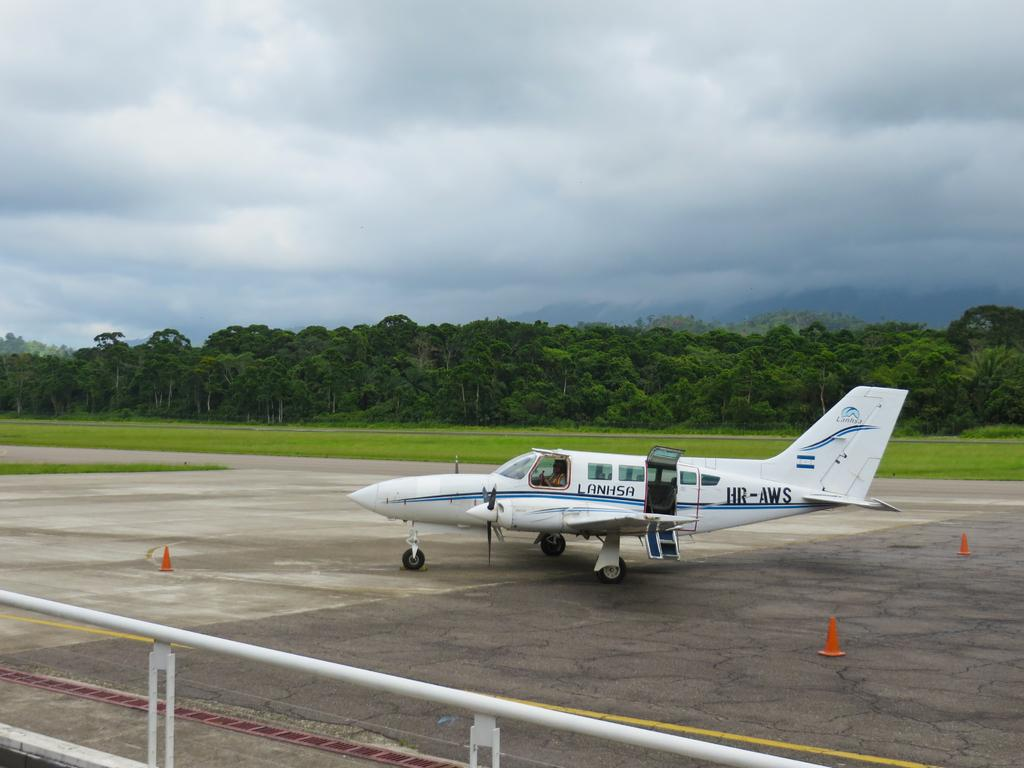<image>
Summarize the visual content of the image. the Lanhsa plane is sitting under a cloudy sky 